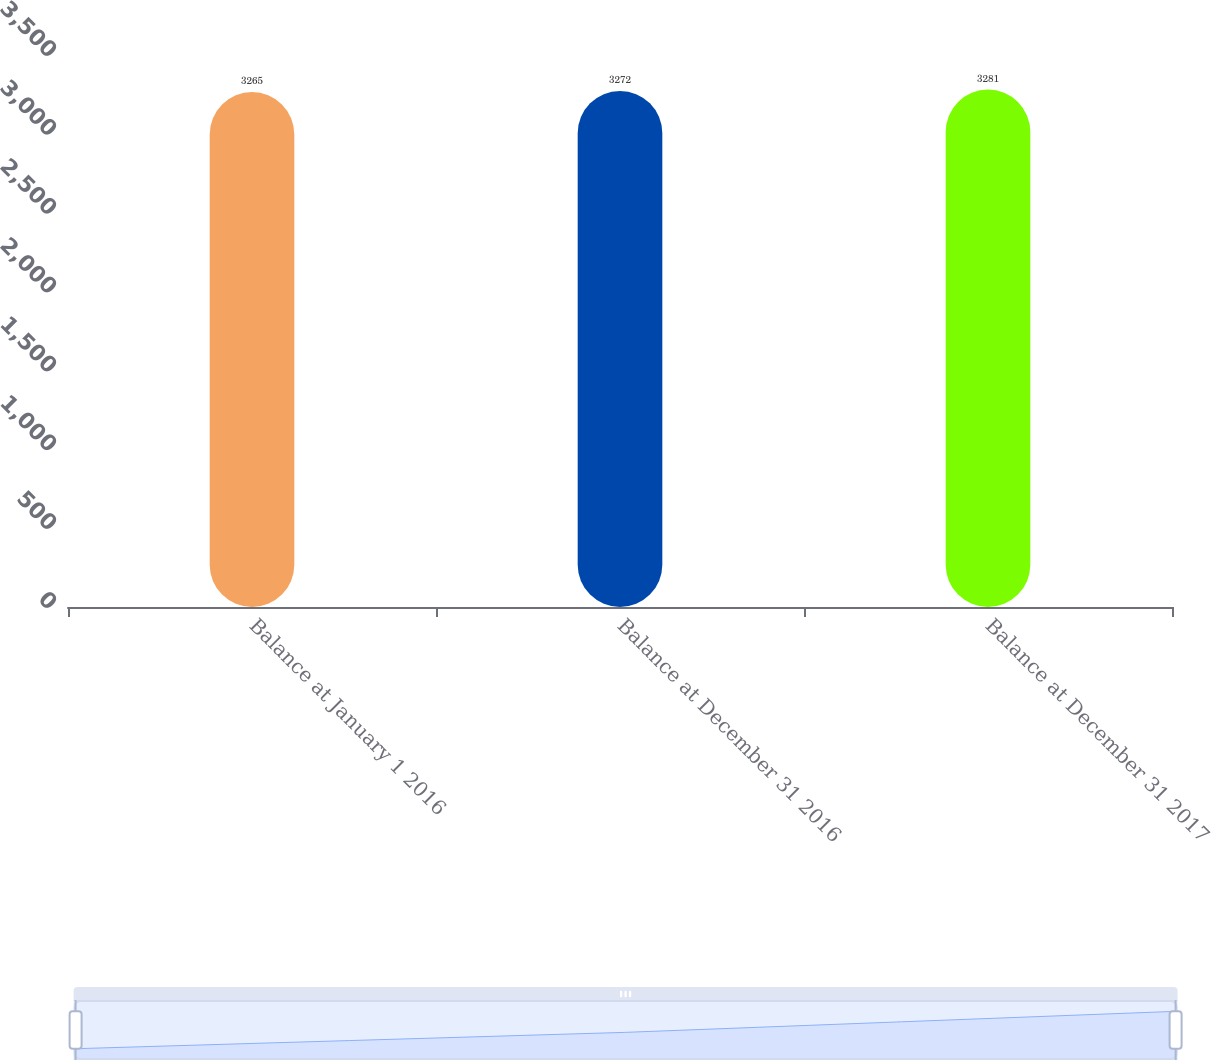Convert chart to OTSL. <chart><loc_0><loc_0><loc_500><loc_500><bar_chart><fcel>Balance at January 1 2016<fcel>Balance at December 31 2016<fcel>Balance at December 31 2017<nl><fcel>3265<fcel>3272<fcel>3281<nl></chart> 